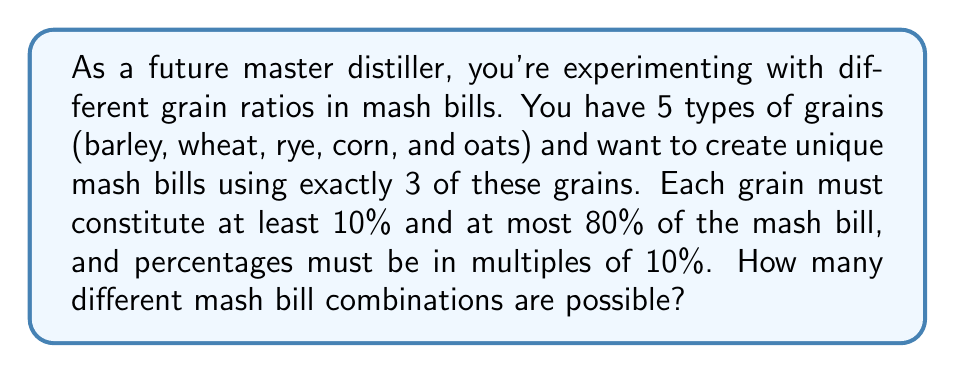Show me your answer to this math problem. Let's approach this step-by-step:

1) First, we need to choose 3 grains out of 5. This can be done in $\binom{5}{3} = 10$ ways.

2) For each combination of 3 grains, we need to determine how many ways we can distribute percentages.

3) Given the constraints (10% minimum, 80% maximum, multiples of 10%), the possible percentages for each grain are: 10%, 20%, 30%, 40%, 50%, 60%, 70%, 80%.

4) We need to find the number of ways to choose 3 numbers from this set that sum to 100%.

5) This is a classic stars and bars problem with restrictions. We can solve it by listing all possibilities:

   10%, 10%, 80%
   10%, 20%, 70%
   10%, 30%, 60%
   10%, 40%, 50%
   20%, 20%, 60%
   20%, 30%, 50%
   20%, 40%, 40%
   30%, 30%, 40%

6) There are 8 ways to distribute the percentages for each combination of 3 grains.

7) By the multiplication principle, the total number of possible mash bill combinations is:

   $$10 \times 8 = 80$$

Therefore, there are 80 different mash bill combinations possible.
Answer: 80 